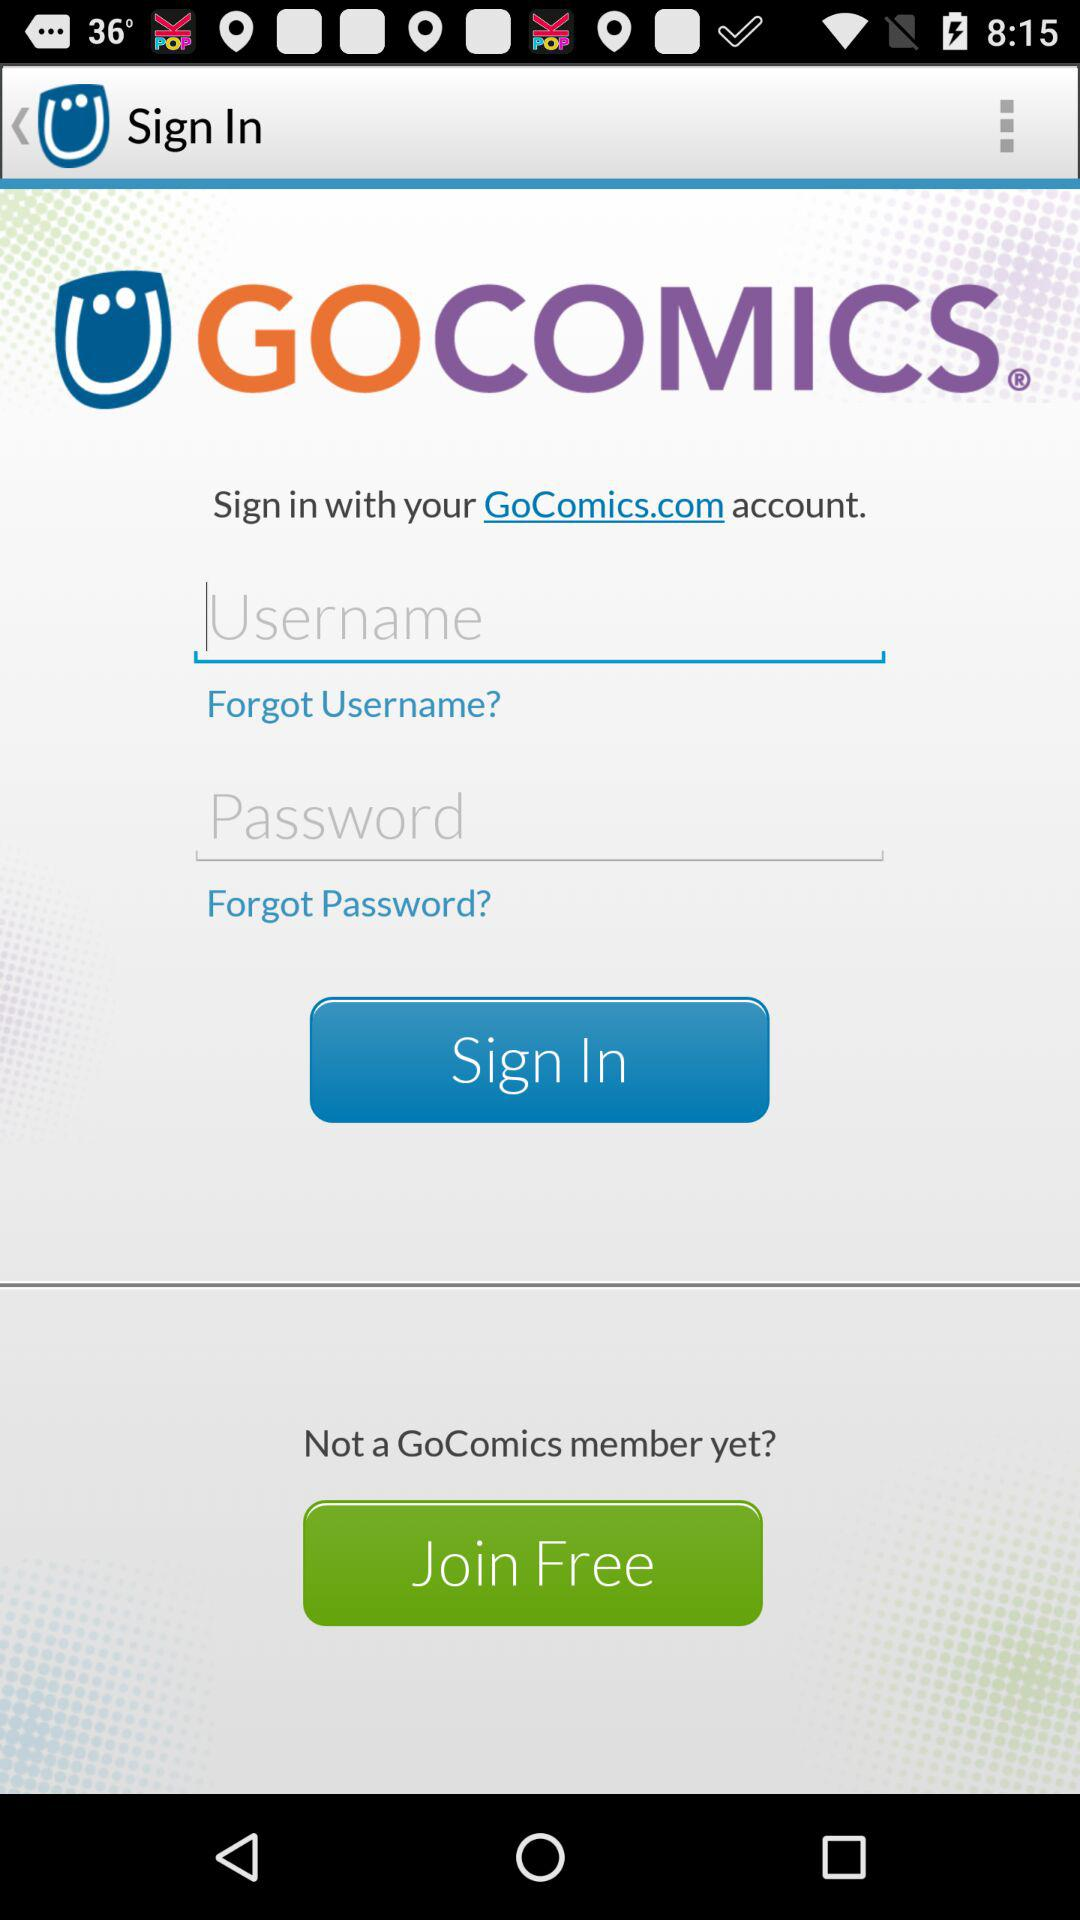What is the application name? The application name is "GOCOMICS®". 